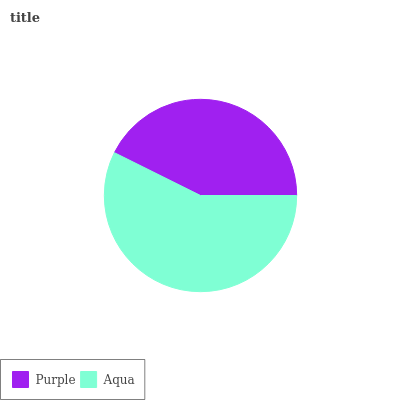Is Purple the minimum?
Answer yes or no. Yes. Is Aqua the maximum?
Answer yes or no. Yes. Is Aqua the minimum?
Answer yes or no. No. Is Aqua greater than Purple?
Answer yes or no. Yes. Is Purple less than Aqua?
Answer yes or no. Yes. Is Purple greater than Aqua?
Answer yes or no. No. Is Aqua less than Purple?
Answer yes or no. No. Is Aqua the high median?
Answer yes or no. Yes. Is Purple the low median?
Answer yes or no. Yes. Is Purple the high median?
Answer yes or no. No. Is Aqua the low median?
Answer yes or no. No. 